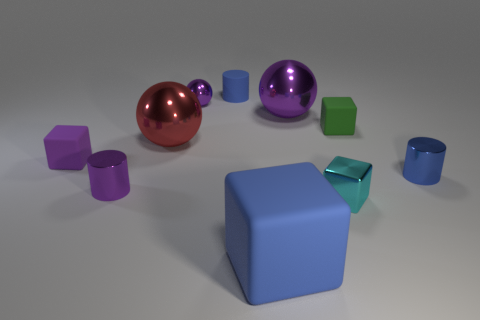What size is the cyan cube that is the same material as the big purple sphere?
Make the answer very short. Small. What size is the metallic cylinder that is to the right of the large purple metal object?
Offer a very short reply. Small. How many purple balls have the same size as the blue matte cube?
Give a very brief answer. 1. There is another cylinder that is the same color as the rubber cylinder; what is its size?
Give a very brief answer. Small. Are there any tiny balls that have the same color as the big matte thing?
Your response must be concise. No. There is a ball that is the same size as the purple cylinder; what is its color?
Offer a very short reply. Purple. There is a metal block; is it the same color as the big shiny sphere to the right of the small blue matte cylinder?
Your answer should be very brief. No. The small shiny cube has what color?
Your response must be concise. Cyan. There is a blue object that is to the right of the small cyan thing; what is its material?
Ensure brevity in your answer.  Metal. There is another purple matte object that is the same shape as the large matte thing; what size is it?
Keep it short and to the point. Small. 